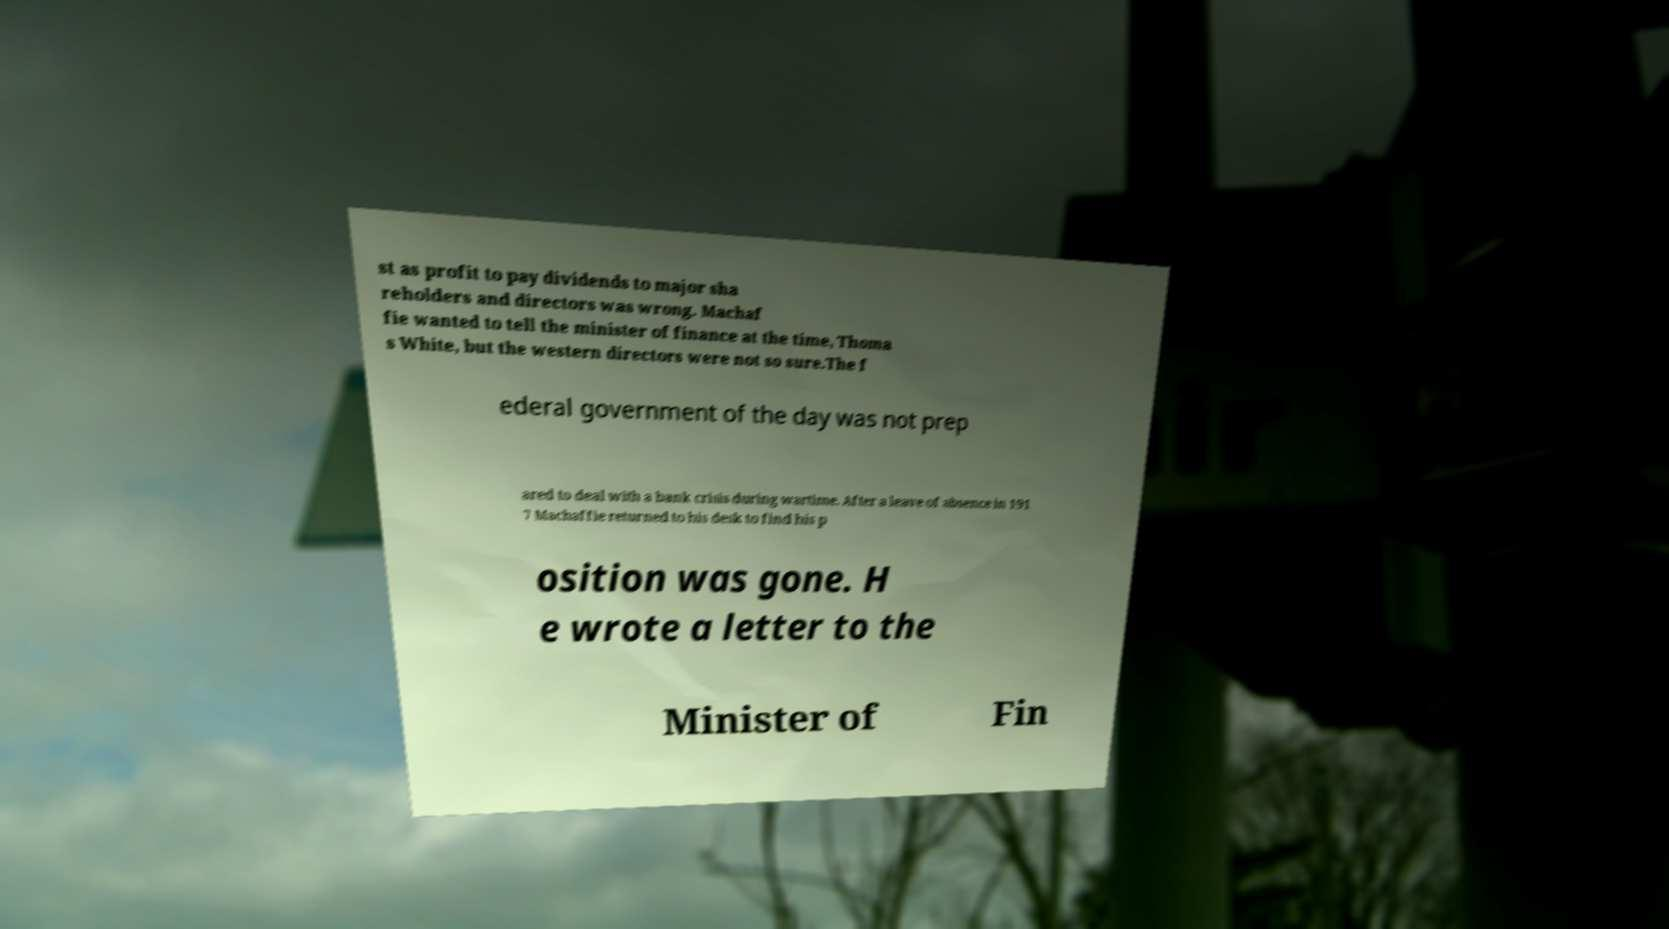I need the written content from this picture converted into text. Can you do that? st as profit to pay dividends to major sha reholders and directors was wrong. Machaf fie wanted to tell the minister of finance at the time, Thoma s White, but the western directors were not so sure.The f ederal government of the day was not prep ared to deal with a bank crisis during wartime. After a leave of absence in 191 7 Machaffie returned to his desk to find his p osition was gone. H e wrote a letter to the Minister of Fin 